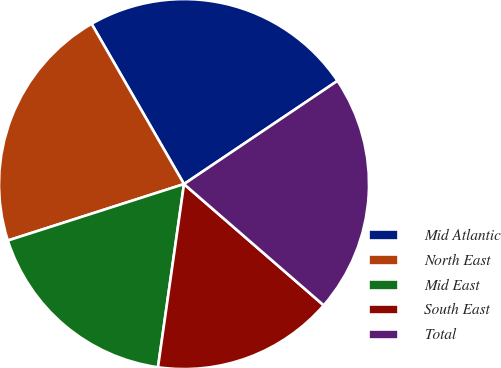Convert chart to OTSL. <chart><loc_0><loc_0><loc_500><loc_500><pie_chart><fcel>Mid Atlantic<fcel>North East<fcel>Mid East<fcel>South East<fcel>Total<nl><fcel>23.9%<fcel>21.61%<fcel>17.82%<fcel>15.87%<fcel>20.8%<nl></chart> 